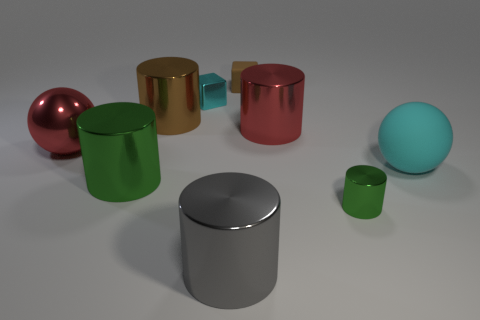There is a large ball that is made of the same material as the small green object; what color is it?
Offer a very short reply. Red. How many large things are the same material as the red cylinder?
Your answer should be very brief. 4. What number of objects are purple metal things or cyan things that are in front of the brown metallic thing?
Ensure brevity in your answer.  1. Does the sphere left of the large red cylinder have the same material as the large cyan thing?
Offer a terse response. No. What color is the other rubber thing that is the same size as the gray thing?
Your response must be concise. Cyan. Are there any gray objects that have the same shape as the brown rubber object?
Ensure brevity in your answer.  No. The big thing that is in front of the green metallic cylinder on the right side of the big thing that is in front of the small green shiny object is what color?
Provide a succinct answer. Gray. What number of shiny objects are either small green things or big cyan balls?
Ensure brevity in your answer.  1. Are there more metal objects that are left of the tiny cyan cube than tiny green cylinders that are in front of the gray object?
Offer a terse response. Yes. How many other things are there of the same size as the brown block?
Provide a succinct answer. 2. 